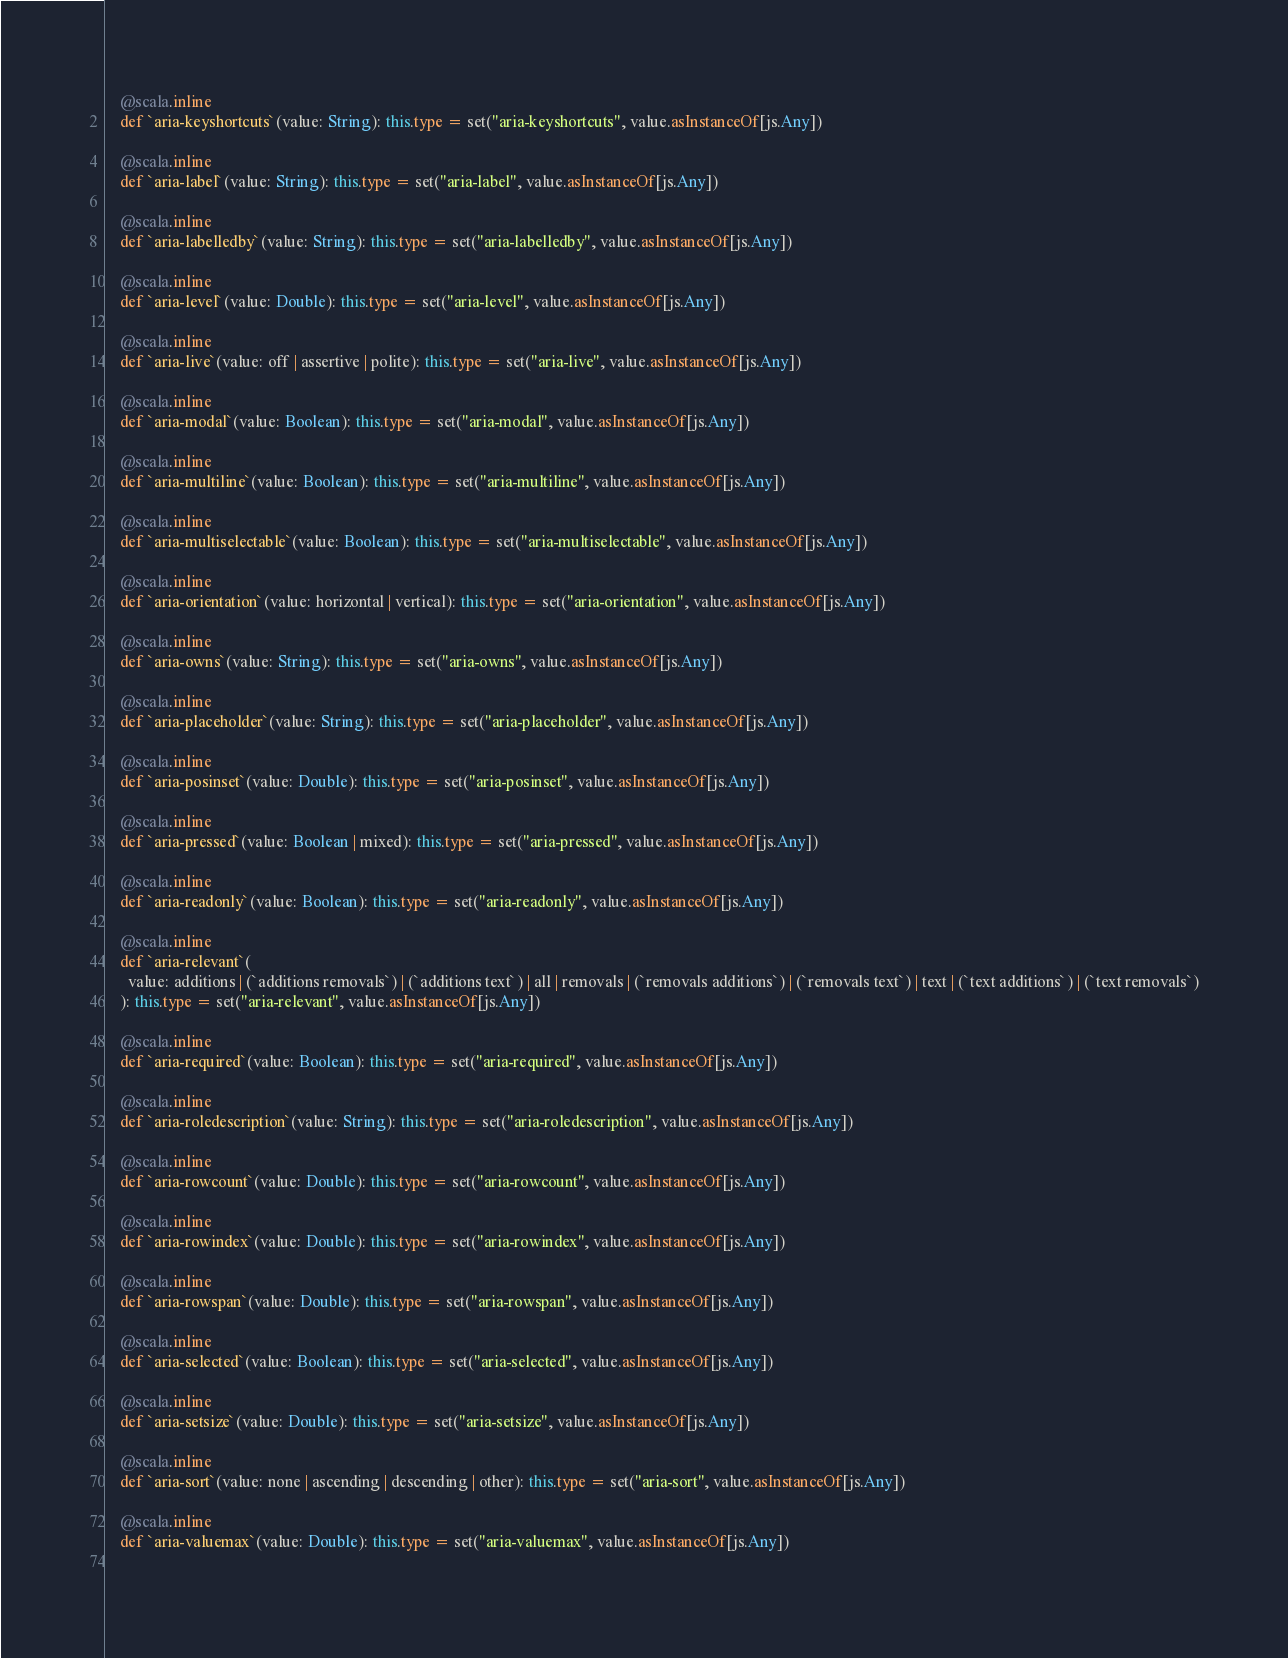Convert code to text. <code><loc_0><loc_0><loc_500><loc_500><_Scala_>    @scala.inline
    def `aria-keyshortcuts`(value: String): this.type = set("aria-keyshortcuts", value.asInstanceOf[js.Any])
    
    @scala.inline
    def `aria-label`(value: String): this.type = set("aria-label", value.asInstanceOf[js.Any])
    
    @scala.inline
    def `aria-labelledby`(value: String): this.type = set("aria-labelledby", value.asInstanceOf[js.Any])
    
    @scala.inline
    def `aria-level`(value: Double): this.type = set("aria-level", value.asInstanceOf[js.Any])
    
    @scala.inline
    def `aria-live`(value: off | assertive | polite): this.type = set("aria-live", value.asInstanceOf[js.Any])
    
    @scala.inline
    def `aria-modal`(value: Boolean): this.type = set("aria-modal", value.asInstanceOf[js.Any])
    
    @scala.inline
    def `aria-multiline`(value: Boolean): this.type = set("aria-multiline", value.asInstanceOf[js.Any])
    
    @scala.inline
    def `aria-multiselectable`(value: Boolean): this.type = set("aria-multiselectable", value.asInstanceOf[js.Any])
    
    @scala.inline
    def `aria-orientation`(value: horizontal | vertical): this.type = set("aria-orientation", value.asInstanceOf[js.Any])
    
    @scala.inline
    def `aria-owns`(value: String): this.type = set("aria-owns", value.asInstanceOf[js.Any])
    
    @scala.inline
    def `aria-placeholder`(value: String): this.type = set("aria-placeholder", value.asInstanceOf[js.Any])
    
    @scala.inline
    def `aria-posinset`(value: Double): this.type = set("aria-posinset", value.asInstanceOf[js.Any])
    
    @scala.inline
    def `aria-pressed`(value: Boolean | mixed): this.type = set("aria-pressed", value.asInstanceOf[js.Any])
    
    @scala.inline
    def `aria-readonly`(value: Boolean): this.type = set("aria-readonly", value.asInstanceOf[js.Any])
    
    @scala.inline
    def `aria-relevant`(
      value: additions | (`additions removals`) | (`additions text`) | all | removals | (`removals additions`) | (`removals text`) | text | (`text additions`) | (`text removals`)
    ): this.type = set("aria-relevant", value.asInstanceOf[js.Any])
    
    @scala.inline
    def `aria-required`(value: Boolean): this.type = set("aria-required", value.asInstanceOf[js.Any])
    
    @scala.inline
    def `aria-roledescription`(value: String): this.type = set("aria-roledescription", value.asInstanceOf[js.Any])
    
    @scala.inline
    def `aria-rowcount`(value: Double): this.type = set("aria-rowcount", value.asInstanceOf[js.Any])
    
    @scala.inline
    def `aria-rowindex`(value: Double): this.type = set("aria-rowindex", value.asInstanceOf[js.Any])
    
    @scala.inline
    def `aria-rowspan`(value: Double): this.type = set("aria-rowspan", value.asInstanceOf[js.Any])
    
    @scala.inline
    def `aria-selected`(value: Boolean): this.type = set("aria-selected", value.asInstanceOf[js.Any])
    
    @scala.inline
    def `aria-setsize`(value: Double): this.type = set("aria-setsize", value.asInstanceOf[js.Any])
    
    @scala.inline
    def `aria-sort`(value: none | ascending | descending | other): this.type = set("aria-sort", value.asInstanceOf[js.Any])
    
    @scala.inline
    def `aria-valuemax`(value: Double): this.type = set("aria-valuemax", value.asInstanceOf[js.Any])
    </code> 